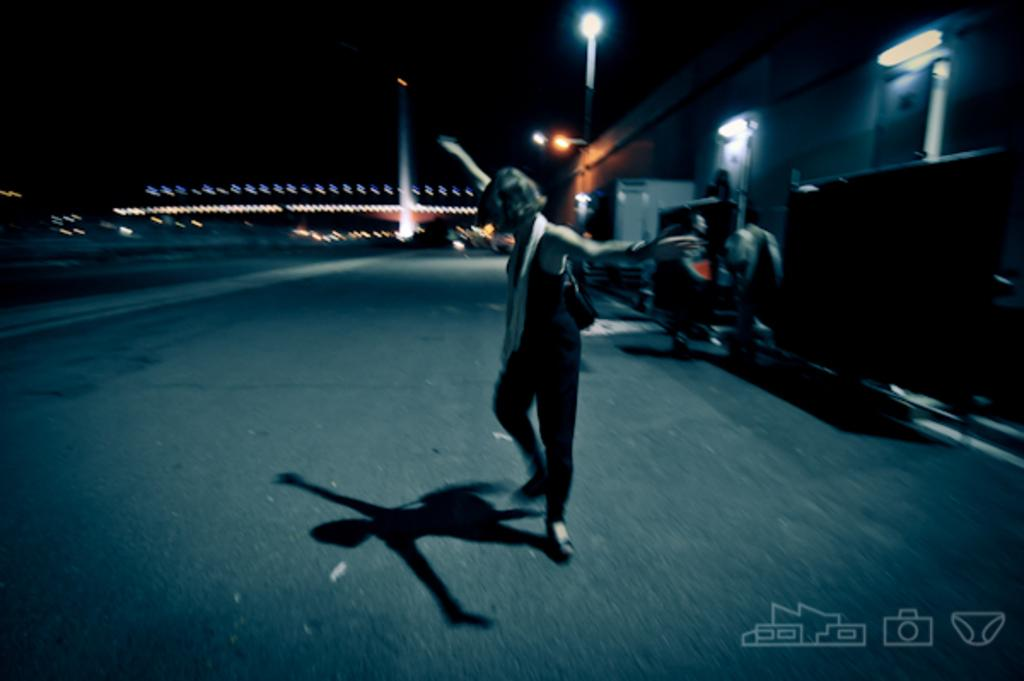What is the main subject of the image? There is a person dancing on the road. What can be seen in the background of the image? There are light poles, buildings, people, and a vehicle in the background. Where are the logos located in the image? The logos are on the right side bottom of the image. What type of hook can be seen in the image? There is no hook present in the image. What medical procedure is being performed in the image? The image does not depict a medical procedure or a hospital setting. 